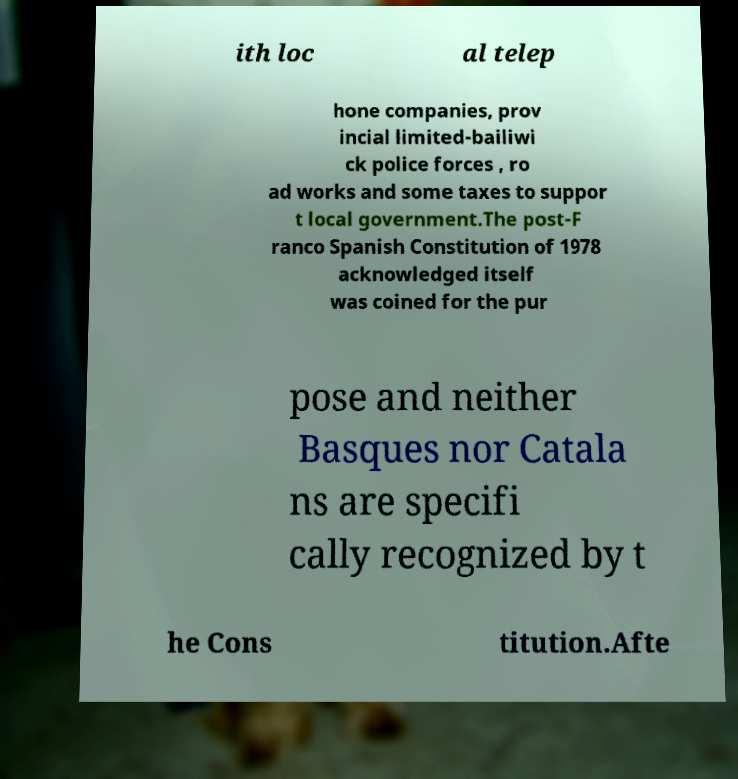What messages or text are displayed in this image? I need them in a readable, typed format. ith loc al telep hone companies, prov incial limited-bailiwi ck police forces , ro ad works and some taxes to suppor t local government.The post-F ranco Spanish Constitution of 1978 acknowledged itself was coined for the pur pose and neither Basques nor Catala ns are specifi cally recognized by t he Cons titution.Afte 